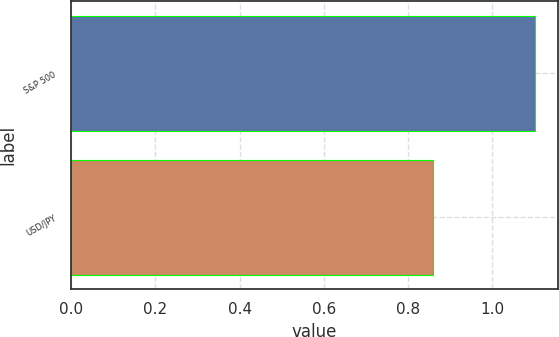Convert chart to OTSL. <chart><loc_0><loc_0><loc_500><loc_500><bar_chart><fcel>S&P 500<fcel>USD/JPY<nl><fcel>1.1<fcel>0.86<nl></chart> 